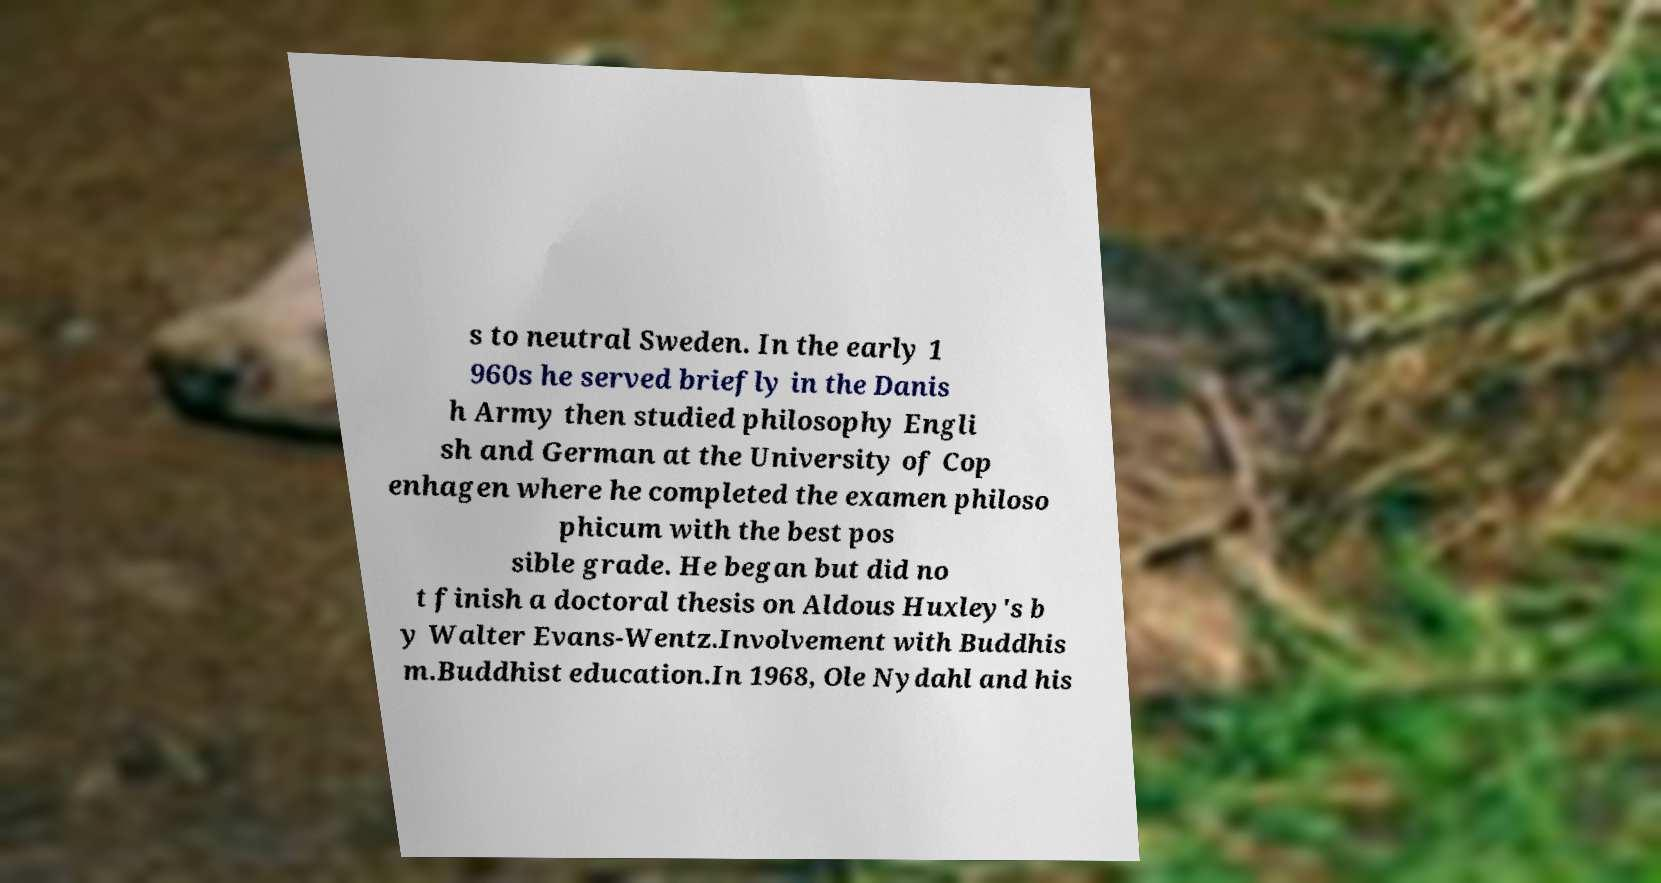What messages or text are displayed in this image? I need them in a readable, typed format. s to neutral Sweden. In the early 1 960s he served briefly in the Danis h Army then studied philosophy Engli sh and German at the University of Cop enhagen where he completed the examen philoso phicum with the best pos sible grade. He began but did no t finish a doctoral thesis on Aldous Huxley's b y Walter Evans-Wentz.Involvement with Buddhis m.Buddhist education.In 1968, Ole Nydahl and his 